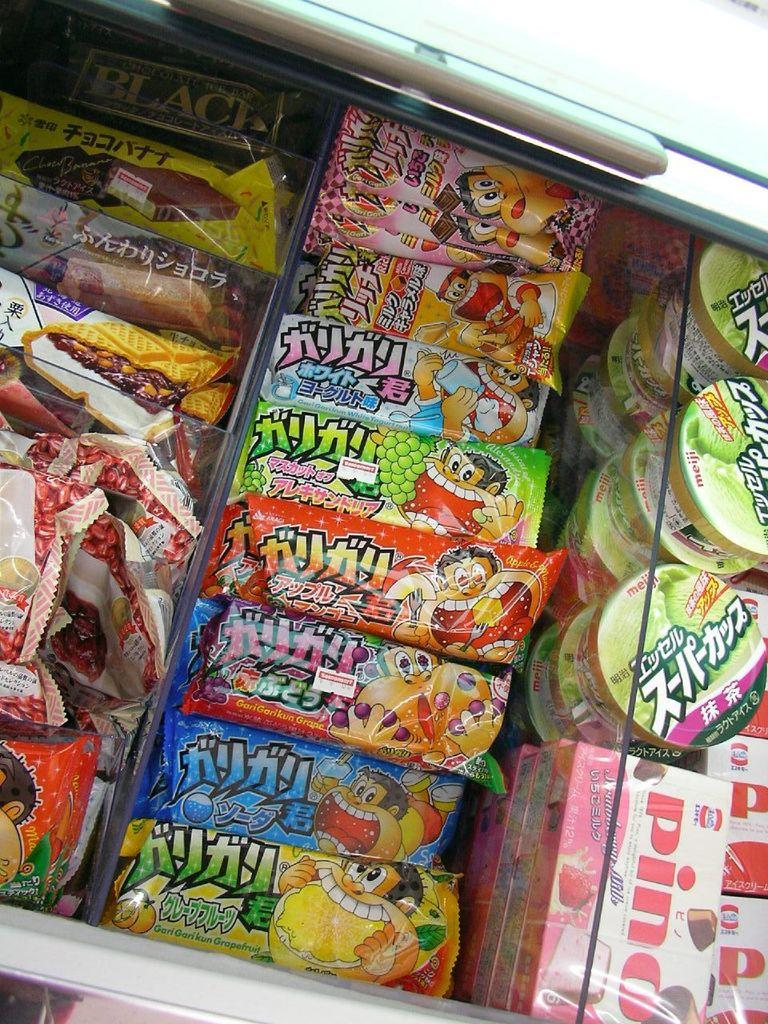<image>
Relay a brief, clear account of the picture shown. a row of treats with one of them labeled as 'pino' 